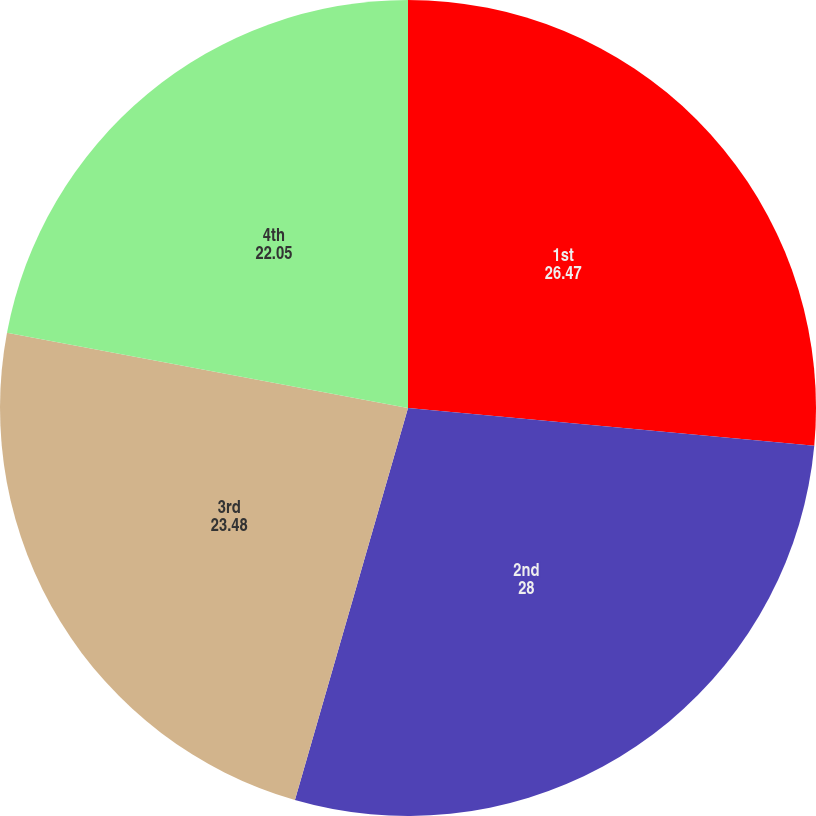Convert chart to OTSL. <chart><loc_0><loc_0><loc_500><loc_500><pie_chart><fcel>1st<fcel>2nd<fcel>3rd<fcel>4th<nl><fcel>26.47%<fcel>28.0%<fcel>23.48%<fcel>22.05%<nl></chart> 